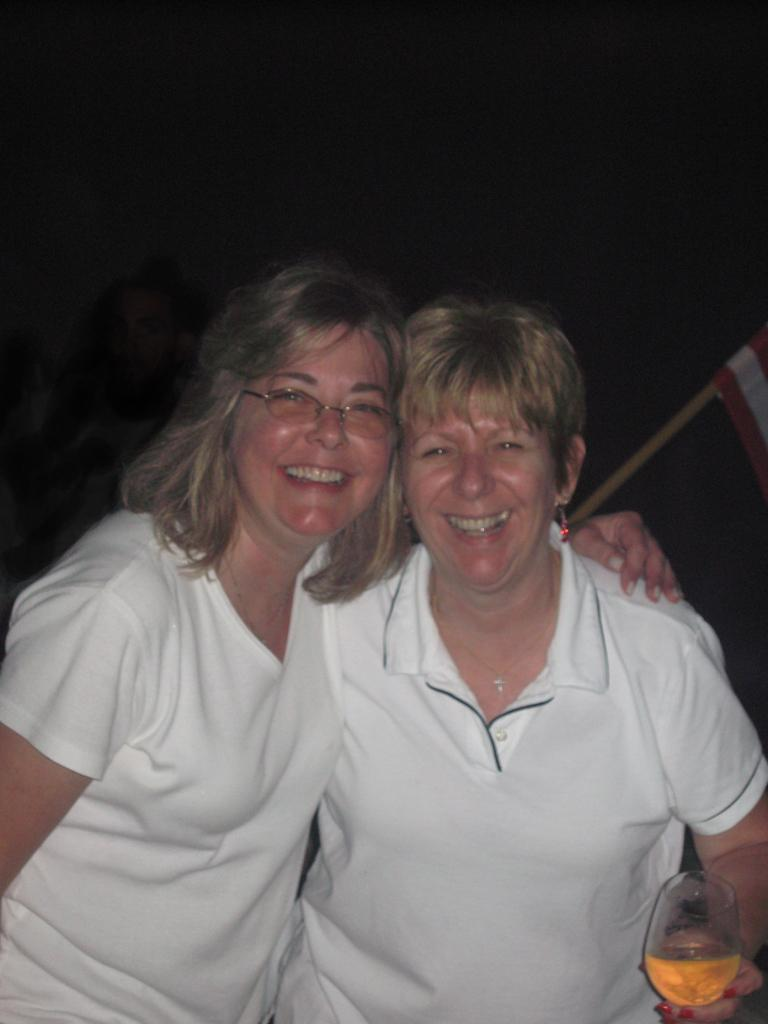How many people are in the image? There are two men in the image. What expressions do the men have? Both men are smiling. What objects are the men holding? Each man is holding a wine glass. What color is the ink on the men's minds in the image? There is no ink or mention of minds in the image; it features two men holding wine glasses and smiling. 